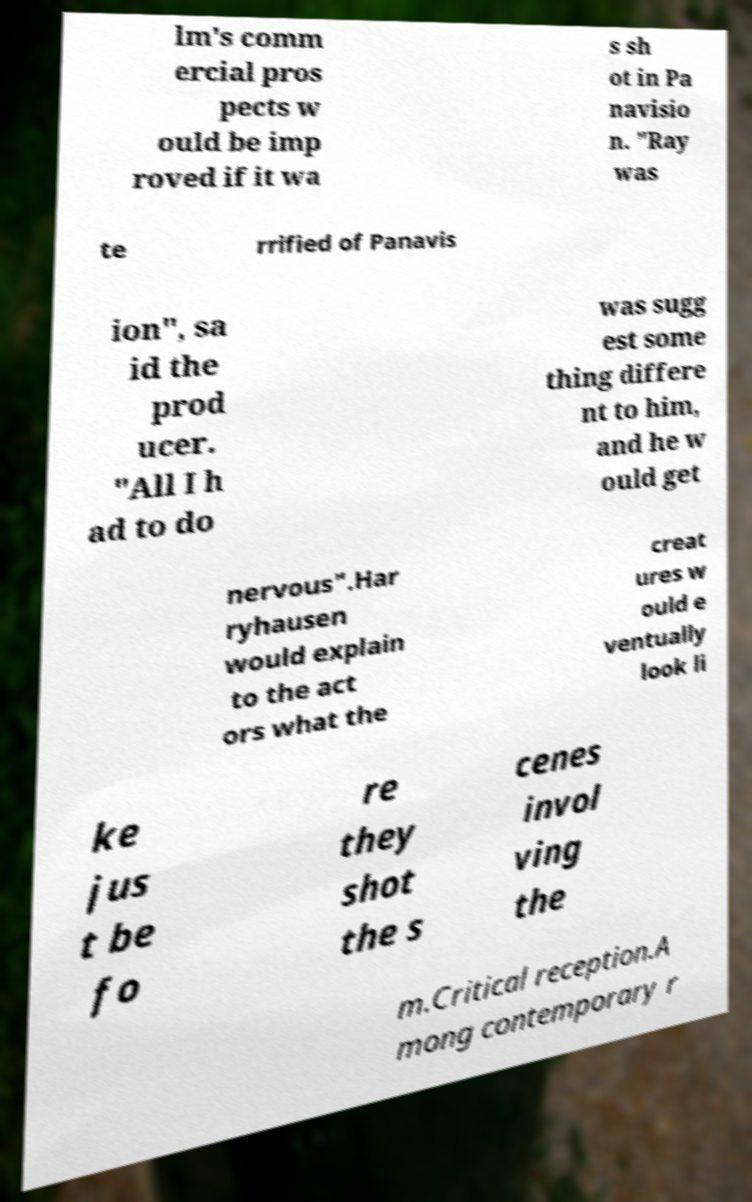What messages or text are displayed in this image? I need them in a readable, typed format. lm's comm ercial pros pects w ould be imp roved if it wa s sh ot in Pa navisio n. "Ray was te rrified of Panavis ion", sa id the prod ucer. "All I h ad to do was sugg est some thing differe nt to him, and he w ould get nervous".Har ryhausen would explain to the act ors what the creat ures w ould e ventually look li ke jus t be fo re they shot the s cenes invol ving the m.Critical reception.A mong contemporary r 